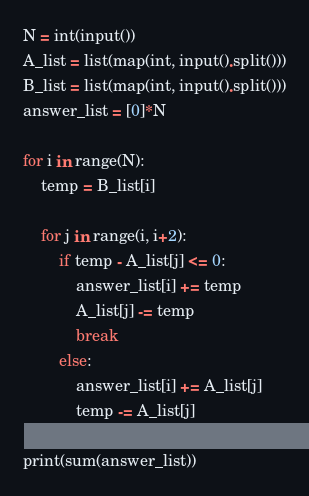<code> <loc_0><loc_0><loc_500><loc_500><_Python_>N = int(input())
A_list = list(map(int, input().split()))
B_list = list(map(int, input().split()))
answer_list = [0]*N

for i in range(N):
    temp = B_list[i]

    for j in range(i, i+2):
        if temp - A_list[j] <= 0:
            answer_list[i] += temp
            A_list[j] -= temp
            break
        else:
            answer_list[i] += A_list[j]
            temp -= A_list[j]

print(sum(answer_list))
</code> 